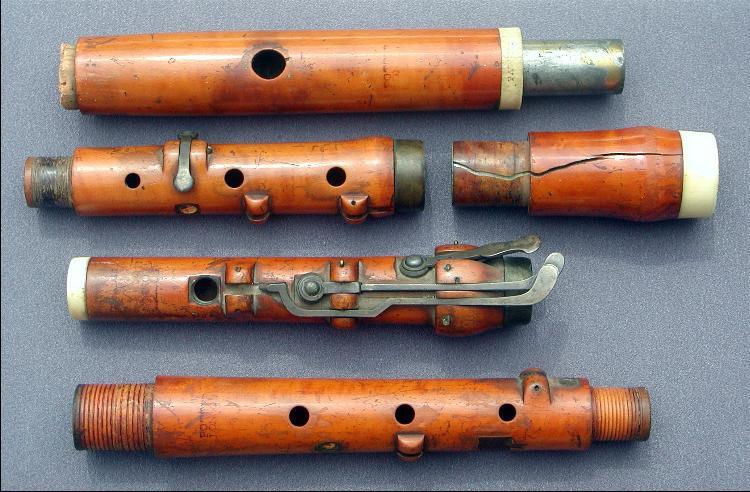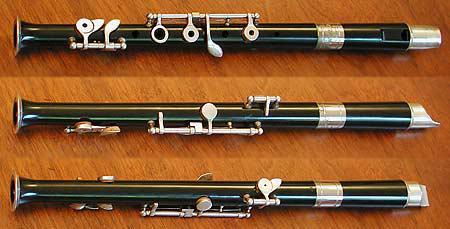The first image is the image on the left, the second image is the image on the right. Examine the images to the left and right. Is the description "In one of the images, the second flute from the bottom is a darker color than the third flute from the bottom." accurate? Answer yes or no. No. The first image is the image on the left, the second image is the image on the right. Analyze the images presented: Is the assertion "One image shows at least three flutes with metal keys displayed horizontally and parallel to one another, and the other image shows at least three rows of wooden flute parts displayed the same way." valid? Answer yes or no. Yes. 